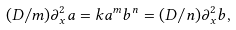Convert formula to latex. <formula><loc_0><loc_0><loc_500><loc_500>( D / m ) \partial _ { x } ^ { 2 } a = k a ^ { m } b ^ { n } = ( D / n ) \partial _ { x } ^ { 2 } b ,</formula> 